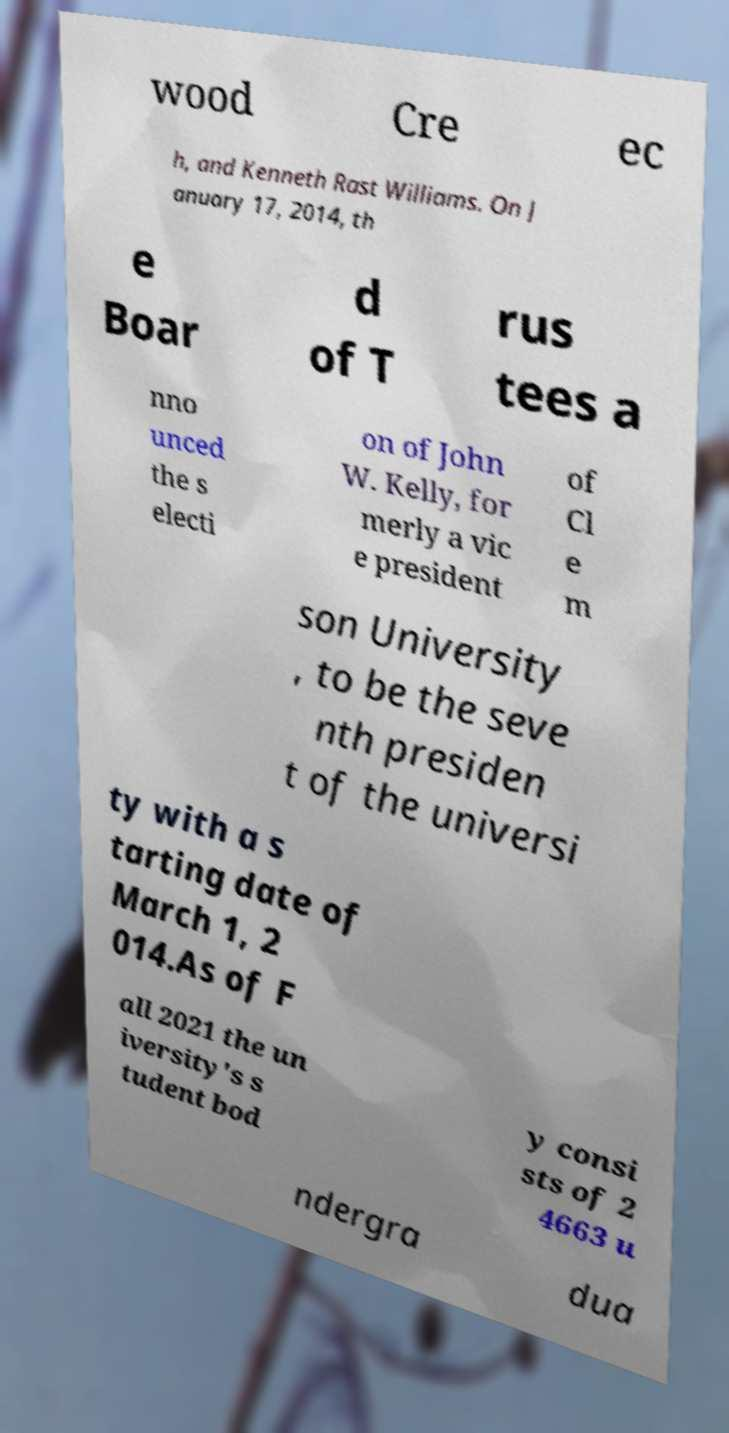For documentation purposes, I need the text within this image transcribed. Could you provide that? wood Cre ec h, and Kenneth Rast Williams. On J anuary 17, 2014, th e Boar d of T rus tees a nno unced the s electi on of John W. Kelly, for merly a vic e president of Cl e m son University , to be the seve nth presiden t of the universi ty with a s tarting date of March 1, 2 014.As of F all 2021 the un iversity's s tudent bod y consi sts of 2 4663 u ndergra dua 